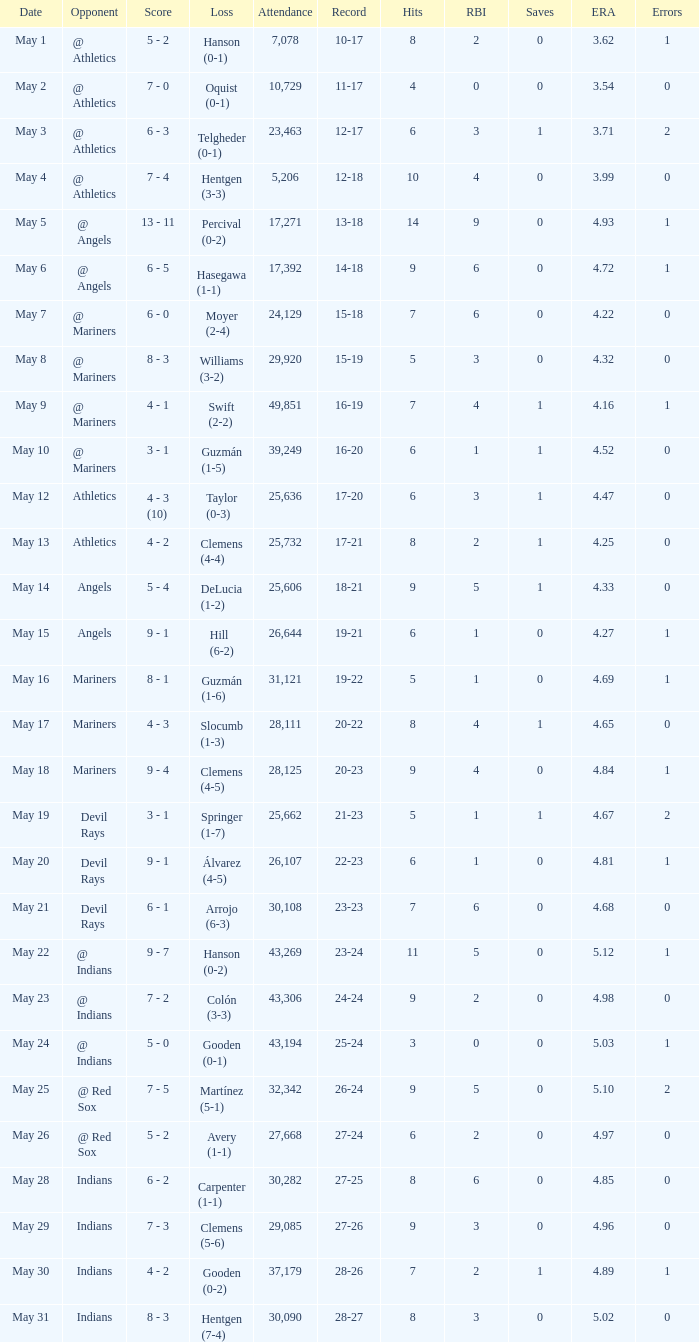When was the record 27-25? May 28. 